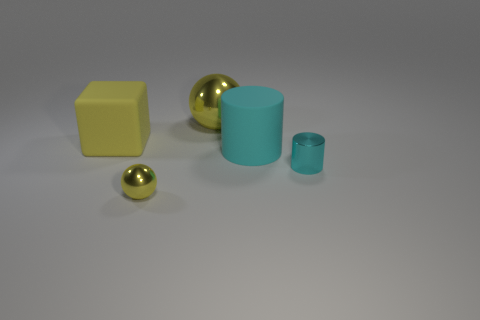What number of large rubber things are the same color as the big block?
Give a very brief answer. 0. Does the matte cylinder have the same color as the metal sphere that is in front of the big rubber block?
Give a very brief answer. No. What number of objects are either small yellow metallic things or big things on the right side of the yellow rubber thing?
Provide a short and direct response. 3. How big is the cyan thing that is in front of the big matte object that is in front of the yellow cube?
Your response must be concise. Small. Are there the same number of cyan things on the left side of the small cyan thing and cyan shiny cylinders on the left side of the tiny yellow shiny thing?
Provide a short and direct response. No. There is a yellow thing that is in front of the matte cylinder; are there any cyan cylinders that are left of it?
Make the answer very short. No. The yellow object that is made of the same material as the big cyan cylinder is what shape?
Your answer should be compact. Cube. Are there any other things that are the same color as the large ball?
Ensure brevity in your answer.  Yes. What material is the object that is on the left side of the sphere in front of the tiny cylinder?
Make the answer very short. Rubber. Is there another metallic object that has the same shape as the big yellow metal thing?
Keep it short and to the point. Yes. 